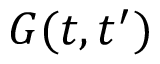<formula> <loc_0><loc_0><loc_500><loc_500>G ( t , t ^ { \prime } )</formula> 